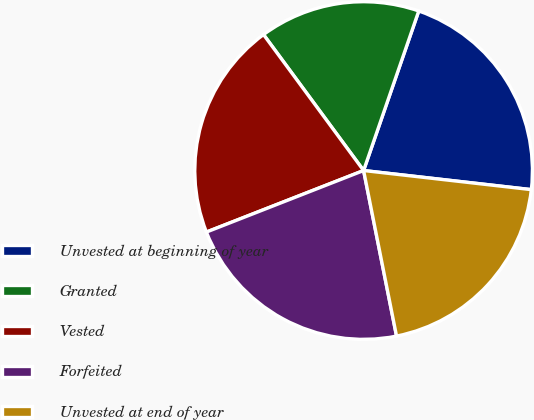Convert chart. <chart><loc_0><loc_0><loc_500><loc_500><pie_chart><fcel>Unvested at beginning of year<fcel>Granted<fcel>Vested<fcel>Forfeited<fcel>Unvested at end of year<nl><fcel>21.51%<fcel>15.4%<fcel>20.84%<fcel>22.19%<fcel>20.07%<nl></chart> 